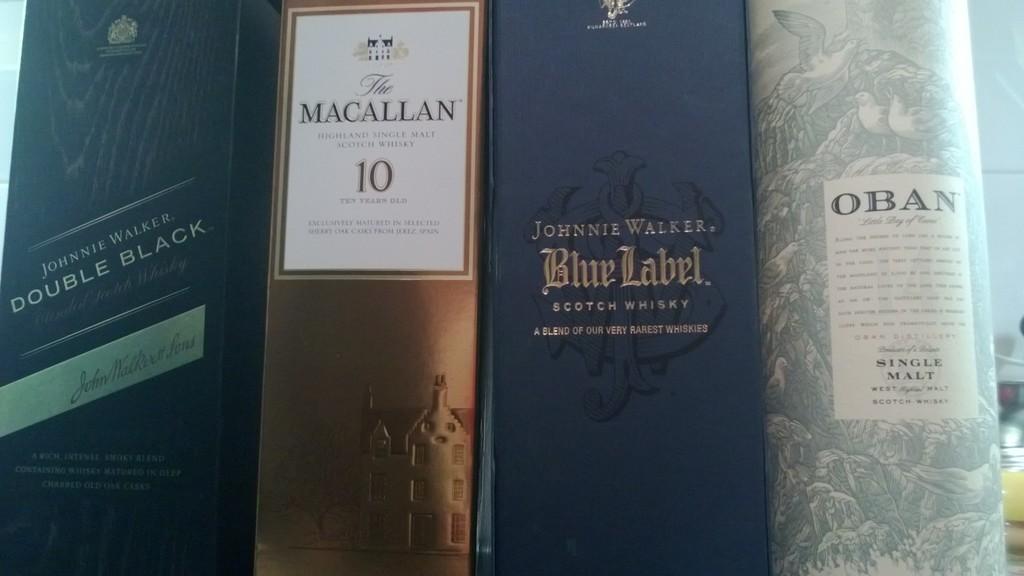What type of johnnie walker is on the far left?
Your answer should be compact. Double black. 